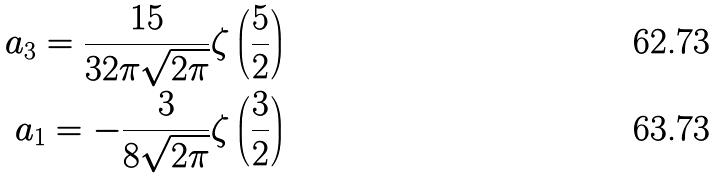<formula> <loc_0><loc_0><loc_500><loc_500>a _ { 3 } = \frac { 1 5 } { 3 2 \pi \sqrt { 2 \pi } } \zeta \left ( \frac { 5 } { 2 } \right ) \\ a _ { 1 } = - \frac { 3 } { 8 \sqrt { 2 \pi } } \zeta \left ( \frac { 3 } { 2 } \right )</formula> 